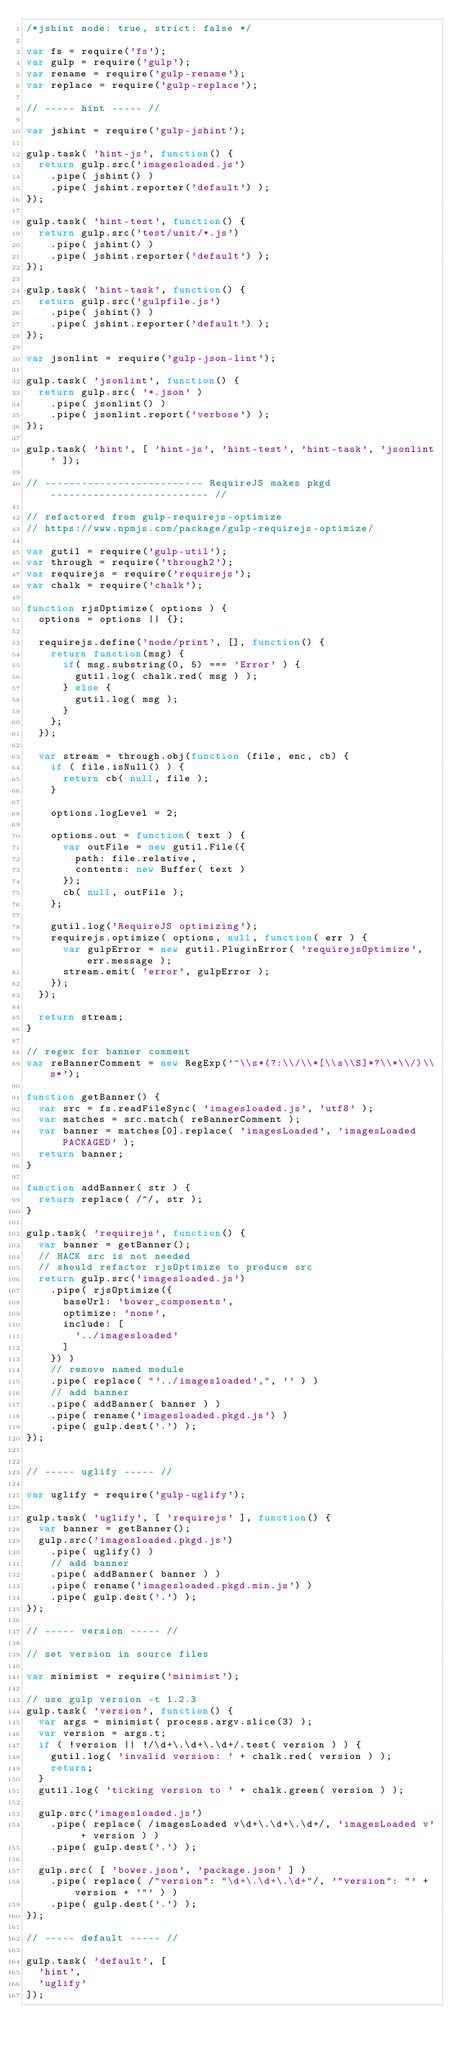<code> <loc_0><loc_0><loc_500><loc_500><_JavaScript_>/*jshint node: true, strict: false */

var fs = require('fs');
var gulp = require('gulp');
var rename = require('gulp-rename');
var replace = require('gulp-replace');

// ----- hint ----- //

var jshint = require('gulp-jshint');

gulp.task( 'hint-js', function() {
  return gulp.src('imagesloaded.js')
    .pipe( jshint() )
    .pipe( jshint.reporter('default') );
});

gulp.task( 'hint-test', function() {
  return gulp.src('test/unit/*.js')
    .pipe( jshint() )
    .pipe( jshint.reporter('default') );
});

gulp.task( 'hint-task', function() {
  return gulp.src('gulpfile.js')
    .pipe( jshint() )
    .pipe( jshint.reporter('default') );
});

var jsonlint = require('gulp-json-lint');

gulp.task( 'jsonlint', function() {
  return gulp.src( '*.json' )
    .pipe( jsonlint() )
    .pipe( jsonlint.report('verbose') );
}); 

gulp.task( 'hint', [ 'hint-js', 'hint-test', 'hint-task', 'jsonlint' ]);

// -------------------------- RequireJS makes pkgd -------------------------- //

// refactored from gulp-requirejs-optimize
// https://www.npmjs.com/package/gulp-requirejs-optimize/

var gutil = require('gulp-util');
var through = require('through2');
var requirejs = require('requirejs');
var chalk = require('chalk');

function rjsOptimize( options ) {
  options = options || {};

  requirejs.define('node/print', [], function() {
    return function(msg) {
      if( msg.substring(0, 5) === 'Error' ) {
        gutil.log( chalk.red( msg ) );
      } else {
        gutil.log( msg );
      }
    };
  });

  var stream = through.obj(function (file, enc, cb) {
    if ( file.isNull() ) {
      return cb( null, file );
    }

    options.logLevel = 2;

    options.out = function( text ) {
      var outFile = new gutil.File({
        path: file.relative,
        contents: new Buffer( text )
      });
      cb( null, outFile );
    };

    gutil.log('RequireJS optimizing');
    requirejs.optimize( options, null, function( err ) {
      var gulpError = new gutil.PluginError( 'requirejsOptimize', err.message );
      stream.emit( 'error', gulpError );
    });
  });

  return stream;
}

// regex for banner comment
var reBannerComment = new RegExp('^\\s*(?:\\/\\*[\\s\\S]*?\\*\\/)\\s*');

function getBanner() {
  var src = fs.readFileSync( 'imagesloaded.js', 'utf8' );
  var matches = src.match( reBannerComment );
  var banner = matches[0].replace( 'imagesLoaded', 'imagesLoaded PACKAGED' );
  return banner;
}

function addBanner( str ) {
  return replace( /^/, str );
}

gulp.task( 'requirejs', function() {
  var banner = getBanner();
  // HACK src is not needed
  // should refactor rjsOptimize to produce src
  return gulp.src('imagesloaded.js')
    .pipe( rjsOptimize({
      baseUrl: 'bower_components',
      optimize: 'none',
      include: [
        '../imagesloaded'
      ]
    }) )
    // remove named module
    .pipe( replace( "'../imagesloaded',", '' ) )
    // add banner
    .pipe( addBanner( banner ) )
    .pipe( rename('imagesloaded.pkgd.js') )
    .pipe( gulp.dest('.') );
});


// ----- uglify ----- //

var uglify = require('gulp-uglify');

gulp.task( 'uglify', [ 'requirejs' ], function() {
  var banner = getBanner();
  gulp.src('imagesloaded.pkgd.js')
    .pipe( uglify() )
    // add banner
    .pipe( addBanner( banner ) )
    .pipe( rename('imagesloaded.pkgd.min.js') )
    .pipe( gulp.dest('.') );
});

// ----- version ----- //

// set version in source files

var minimist = require('minimist');

// use gulp version -t 1.2.3
gulp.task( 'version', function() {
  var args = minimist( process.argv.slice(3) );
  var version = args.t;
  if ( !version || !/\d+\.\d+\.\d+/.test( version ) ) {
    gutil.log( 'invalid version: ' + chalk.red( version ) );
    return;
  }
  gutil.log( 'ticking version to ' + chalk.green( version ) );

  gulp.src('imagesloaded.js')
    .pipe( replace( /imagesLoaded v\d+\.\d+\.\d+/, 'imagesLoaded v' + version ) )
    .pipe( gulp.dest('.') );

  gulp.src( [ 'bower.json', 'package.json' ] )
    .pipe( replace( /"version": "\d+\.\d+\.\d+"/, '"version": "' + version + '"' ) )
    .pipe( gulp.dest('.') );
});

// ----- default ----- //

gulp.task( 'default', [
  'hint',
  'uglify'
]);
</code> 